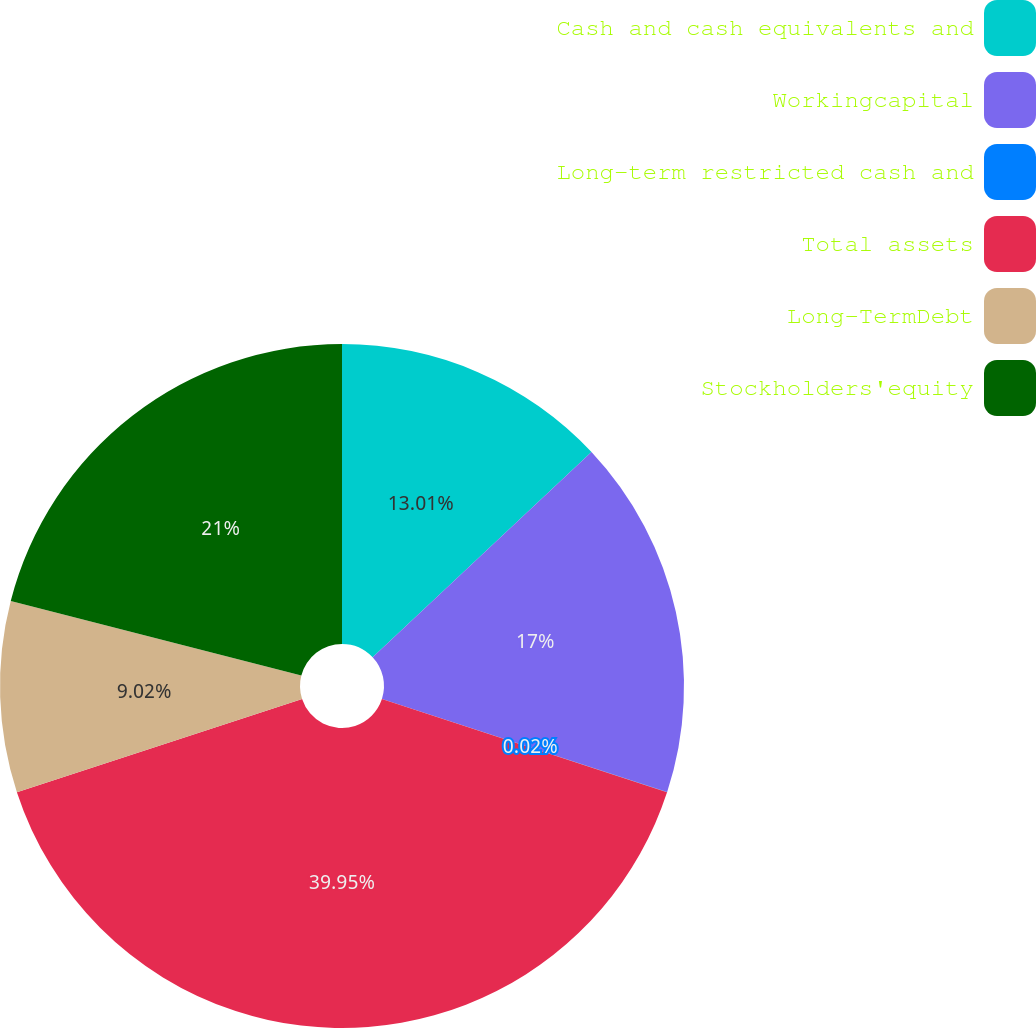<chart> <loc_0><loc_0><loc_500><loc_500><pie_chart><fcel>Cash and cash equivalents and<fcel>Workingcapital<fcel>Long-term restricted cash and<fcel>Total assets<fcel>Long-TermDebt<fcel>Stockholders'equity<nl><fcel>13.01%<fcel>17.0%<fcel>0.02%<fcel>39.94%<fcel>9.02%<fcel>21.0%<nl></chart> 